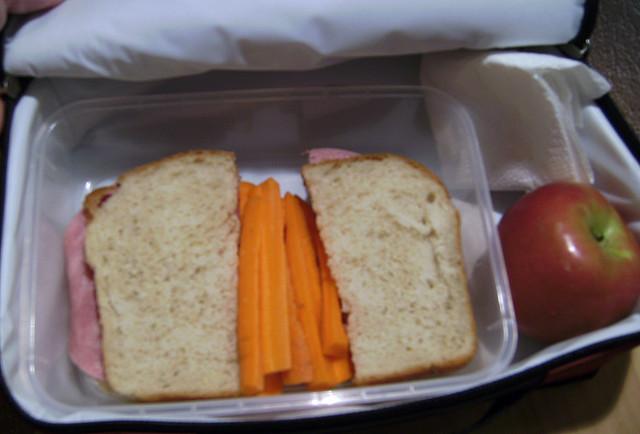What is the container made of?
Quick response, please. Plastic. What colors are the containers?
Quick response, please. Clear. Is the meat pink?
Concise answer only. Yes. What mealtime does this serve?
Give a very brief answer. Lunch. What fruit is in the picture?
Concise answer only. Apple. 